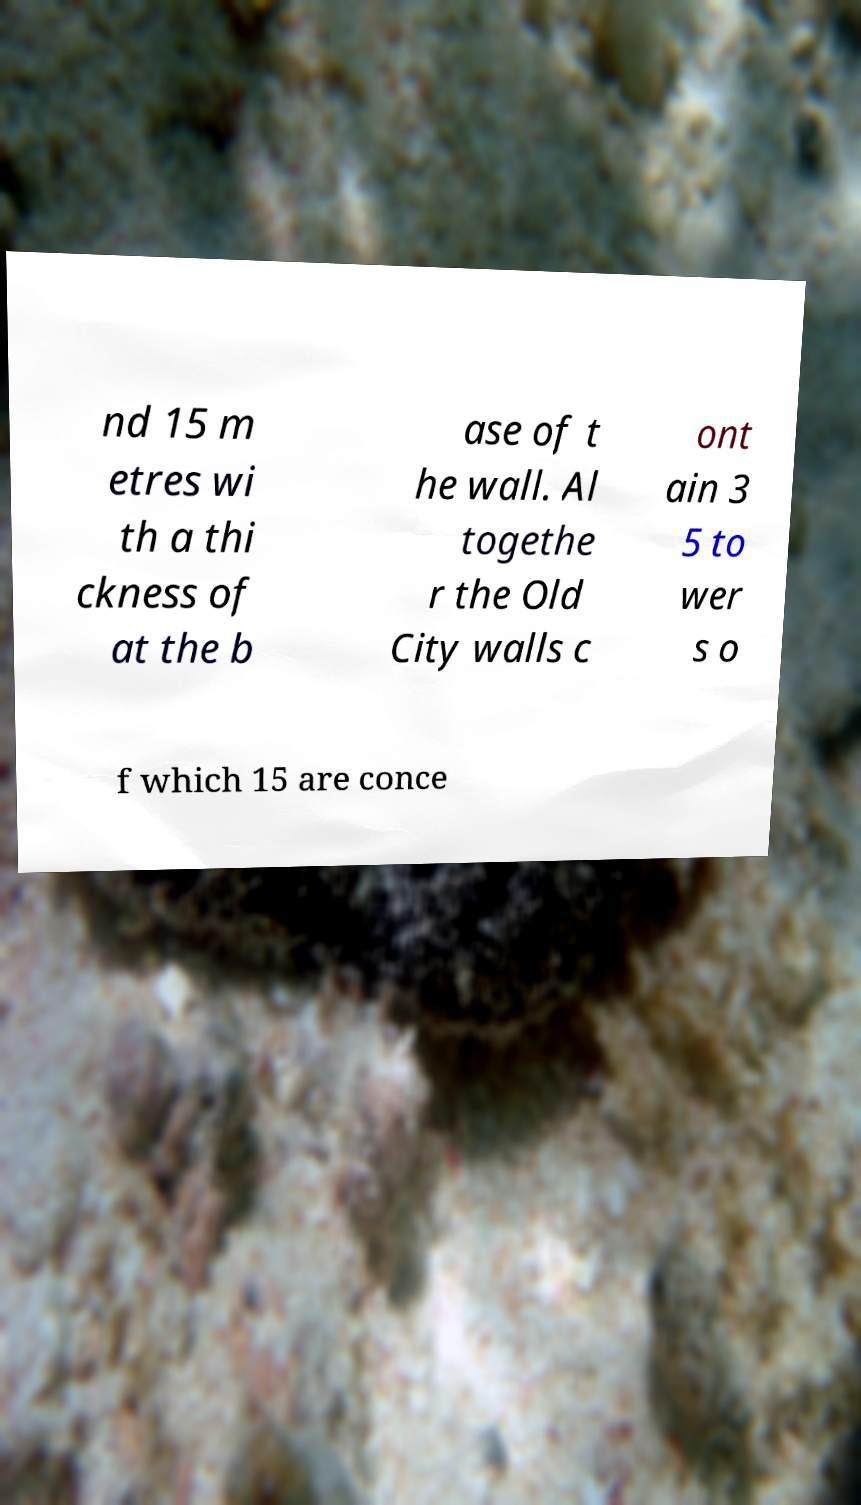Please read and relay the text visible in this image. What does it say? nd 15 m etres wi th a thi ckness of at the b ase of t he wall. Al togethe r the Old City walls c ont ain 3 5 to wer s o f which 15 are conce 